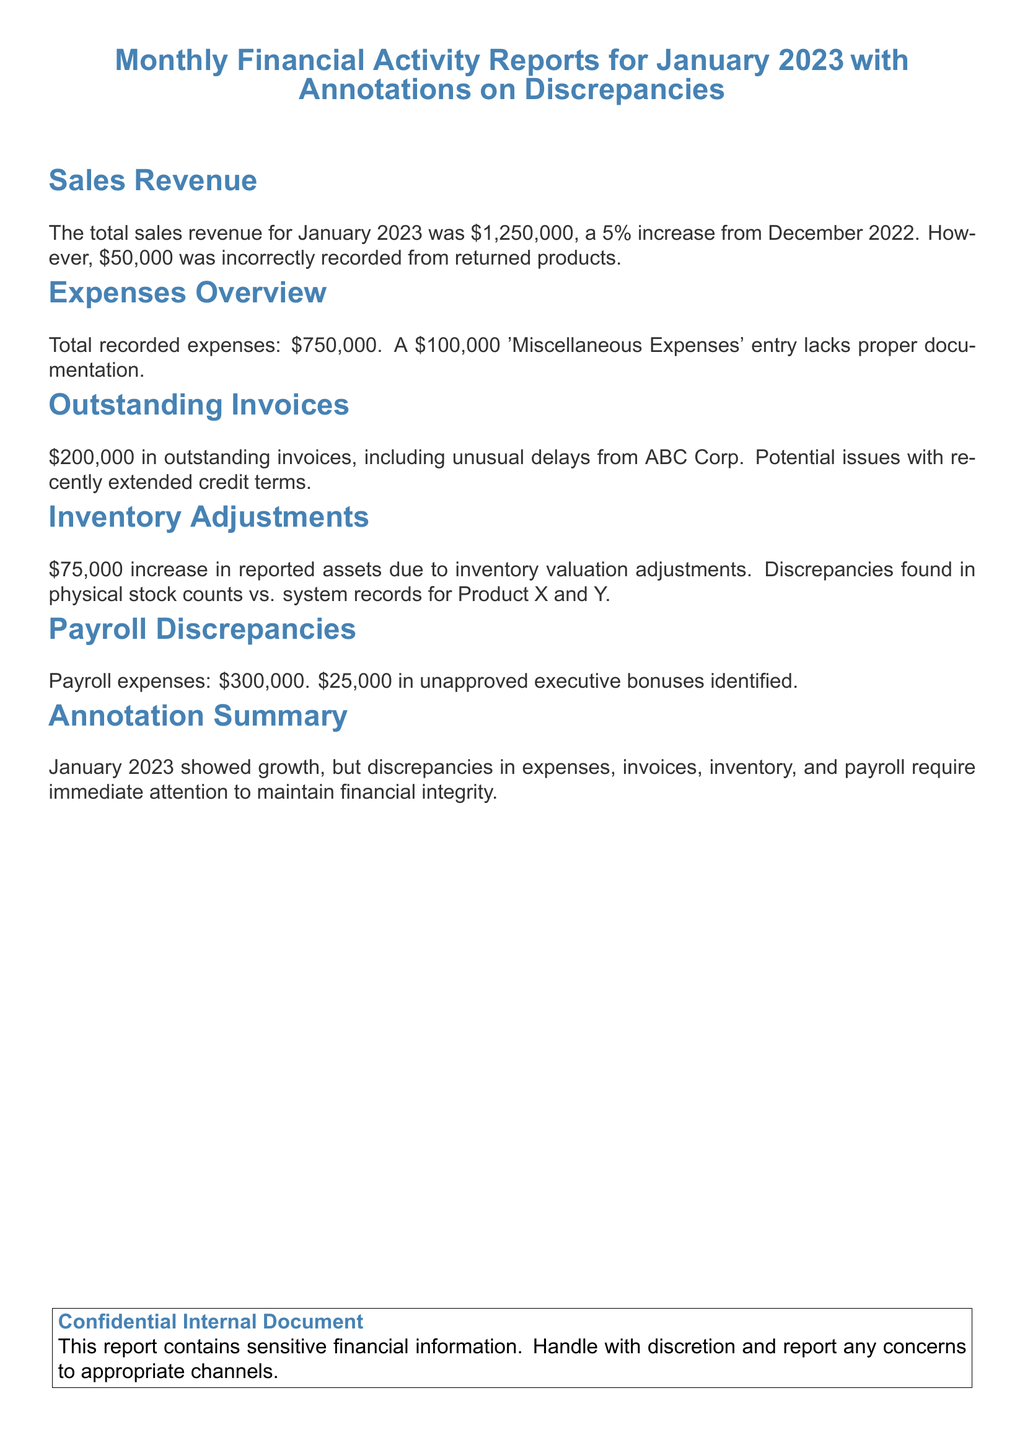What was the total sales revenue for January 2023? The total sales revenue is explicitly stated in the document as $1,250,000.
Answer: $1,250,000 What percentage increase in sales revenue occurred from December 2022 to January 2023? The document notes a 5% increase in sales revenue.
Answer: 5% How much was incorrectly recorded from returned products? The document specifies that $50,000 was incorrectly recorded from returned products.
Answer: $50,000 What amount is listed for outstanding invoices? The outstanding invoices amount is stated as $200,000 in the document.
Answer: $200,000 How much was recorded under 'Miscellaneous Expenses'? The document mentions a $100,000 entry for 'Miscellaneous Expenses.'
Answer: $100,000 What discrepancies were found in the inventory adjustments? The document highlights discrepancies between physical stock counts and system records for Product X and Y.
Answer: Product X and Y What is the total payroll expenses for January 2023? The document states that payroll expenses totaled $300,000.
Answer: $300,000 How much unapproved executive bonuses were identified? The document indicates that $25,000 in unapproved executive bonuses were identified.
Answer: $25,000 What is the document's summary annotation regarding January 2023? The summary annotation warns that discrepancies in various areas highlight the need for immediate attention to maintain financial integrity.
Answer: Immediate attention required 